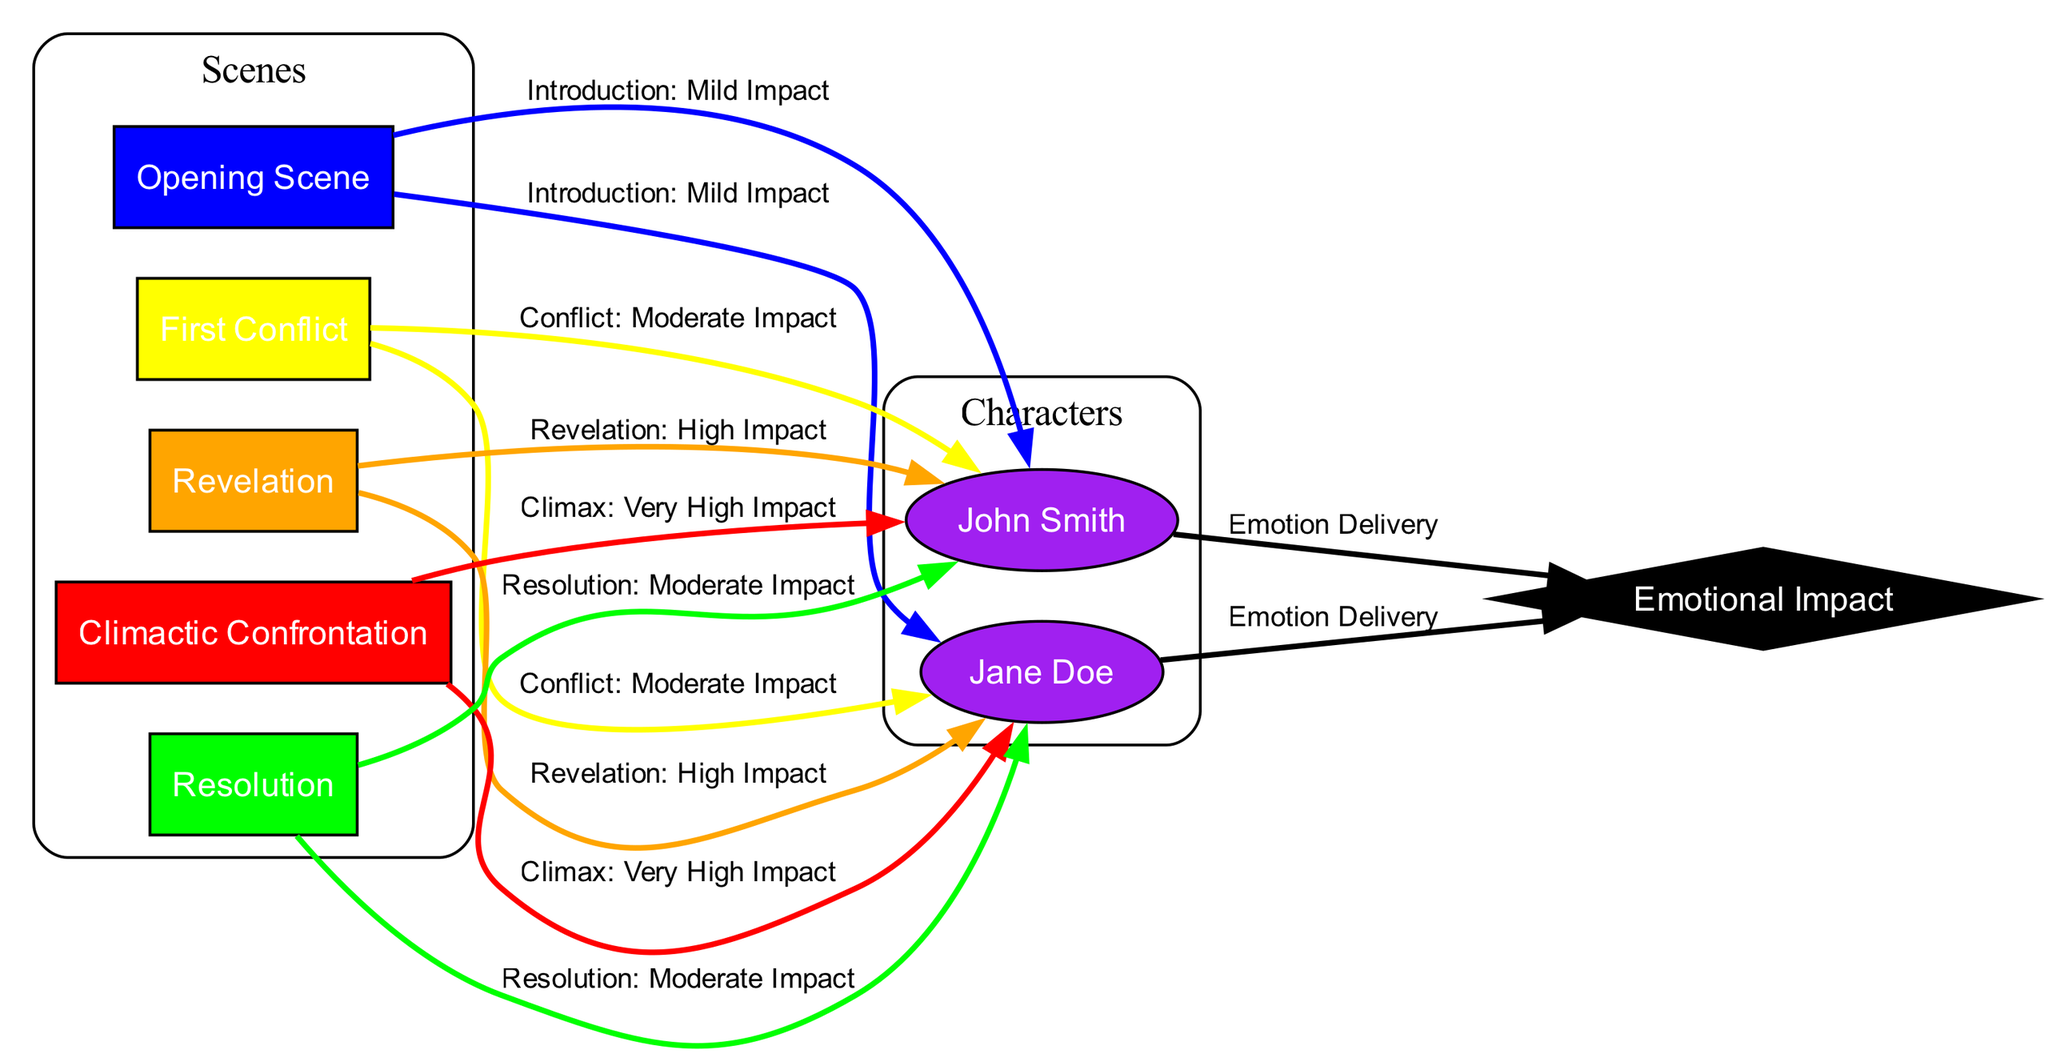What is the color representing the "Climactic Confrontation" scene? In the diagram, the "Climactic Confrontation" scene is denoted by its node, which has the color red assigned to it.
Answer: red How many characters are involved in the dialogue? By examining the nodes labeled with character names, we see two characters: "Jane Doe" and "John Smith", indicating that there are two characters involved in the dialogue.
Answer: two What is the emotional impact label for the "Revelation" scene? The edge connecting the "Revelation" scene to both "Jane Doe" and "John Smith" is labeled "Revelation: High Impact", indicating this specific emotional impact for the scene.
Answer: High Impact Which scene has the highest emotional impact? The "Climactic Confrontation" scene is indicated to have the emotional impact categorized as "Very High Impact", making it the scene with the highest emotional intensity in the heatmap.
Answer: Very High Impact What color indicates a scene with moderate emotional impact? The color yellow is used to indicate scenes with moderate emotional impact, as seen in the edges concerning the "First Conflict" scene.
Answer: yellow Which character's dialogue delivers emotion in the heatmap? Both characters, "Jane Doe" and "John Smith", are connected to "Dialogue Impact" with the edge labeled "Emotion Delivery", meaning that both contribute to the emotional delivery in the narrative.
Answer: Jane Doe and John Smith What is the label for the edge from "scene5" to "Jane_Doe"? The edge from "scene5" to "Jane_Doe" is labeled "Resolution: Moderate Impact", suggesting that this scene's resolution dialogue has a moderate emotional weight.
Answer: Resolution: Moderate Impact How many scenes are depicted in the diagram? The diagram includes five scenes as described by nodes: "Opening Scene", "First Conflict", "Revelation", "Climactic Confrontation", and "Resolution". Thus, counting these nodes gives the total number of scenes.
Answer: five What type of diagram is this? This diagram is a heatmap, specifically designed to illustrate the intensity and emotional impact of dialogues in a character-driven drama.
Answer: heatmap 